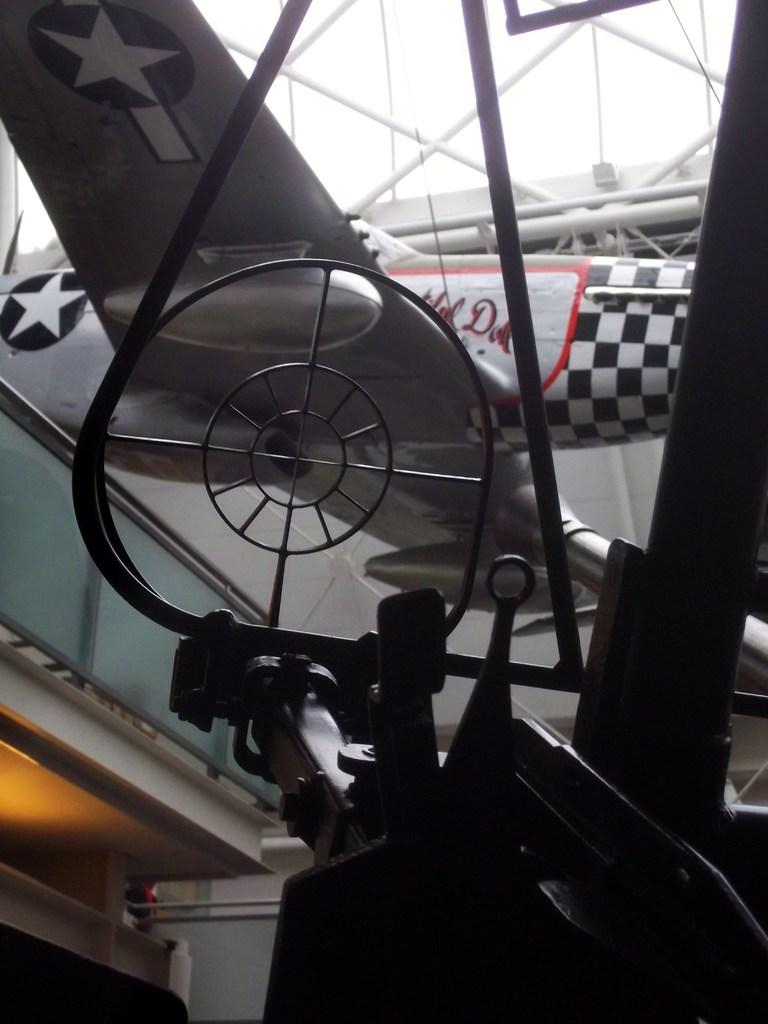What type of aircraft is depicted in the image? There is an artificial aircraft in the image. What color is the aircraft? The aircraft appears to be black in color. What other objects can be seen in the image? There are iron poles in the image. What is the background of the image? There is a wall in the image. What type of reaction can be seen in the morning in the image? There is no reference to a reaction or the morning in the image; it features an artificial aircraft, iron poles, and a wall. 